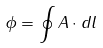Convert formula to latex. <formula><loc_0><loc_0><loc_500><loc_500>\phi = \oint { A } \cdot { d l }</formula> 